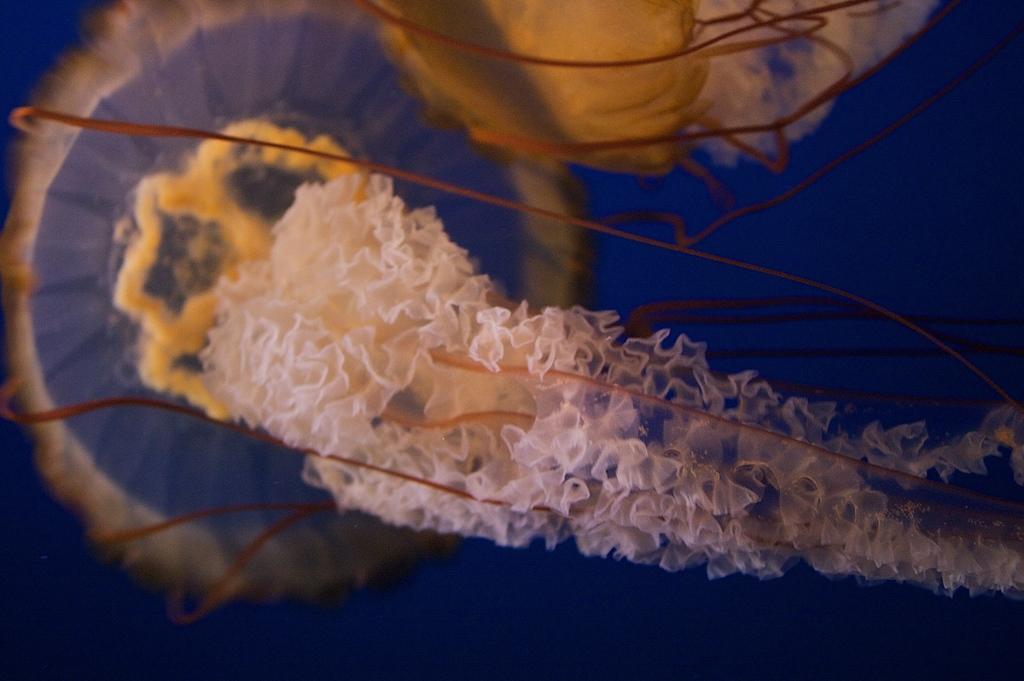Could you give a brief overview of what you see in this image? In this image we can see two jellyfishes. 